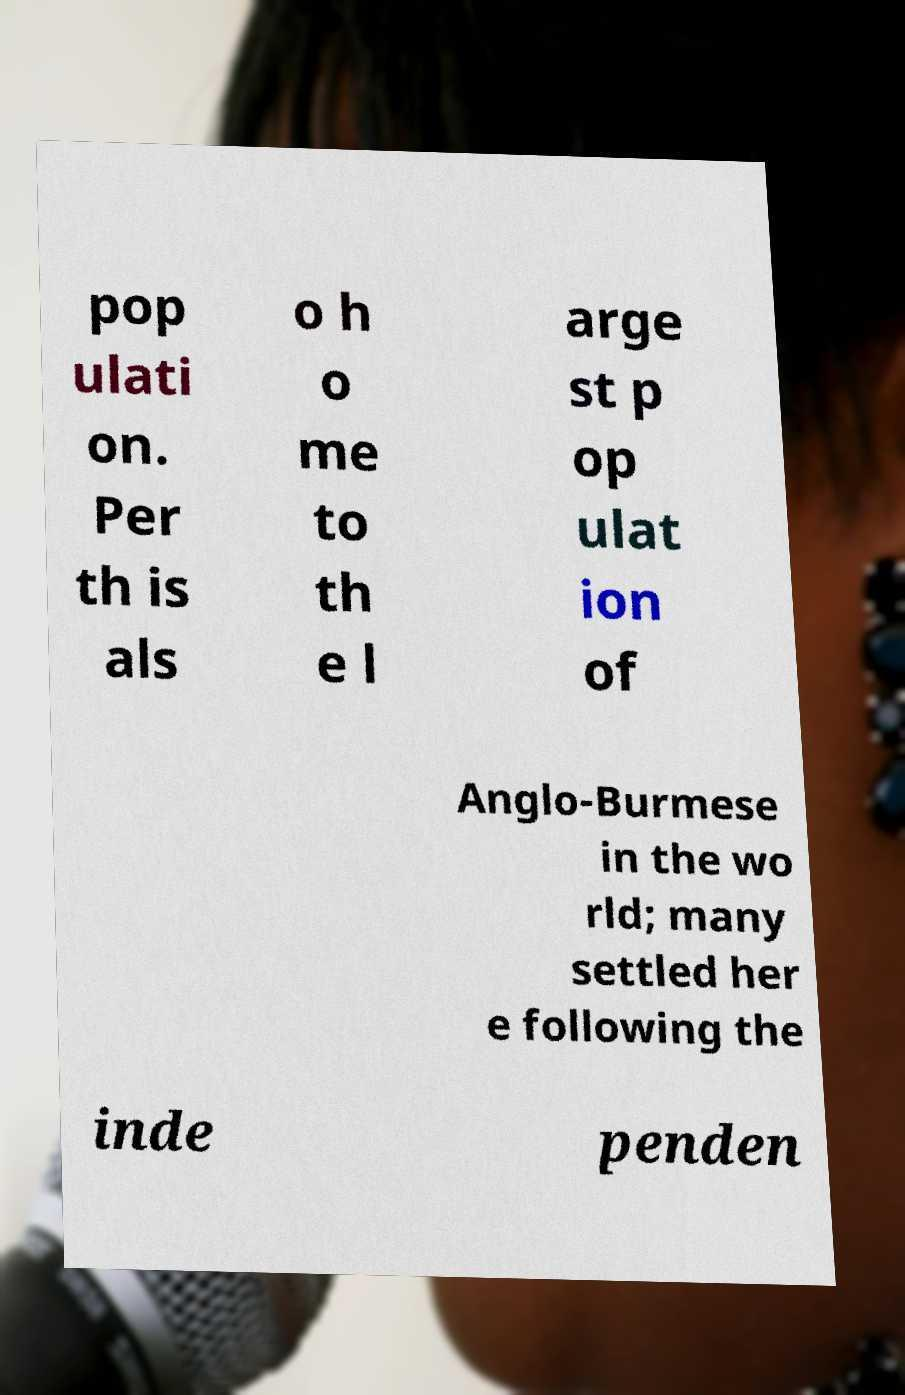Please read and relay the text visible in this image. What does it say? pop ulati on. Per th is als o h o me to th e l arge st p op ulat ion of Anglo-Burmese in the wo rld; many settled her e following the inde penden 